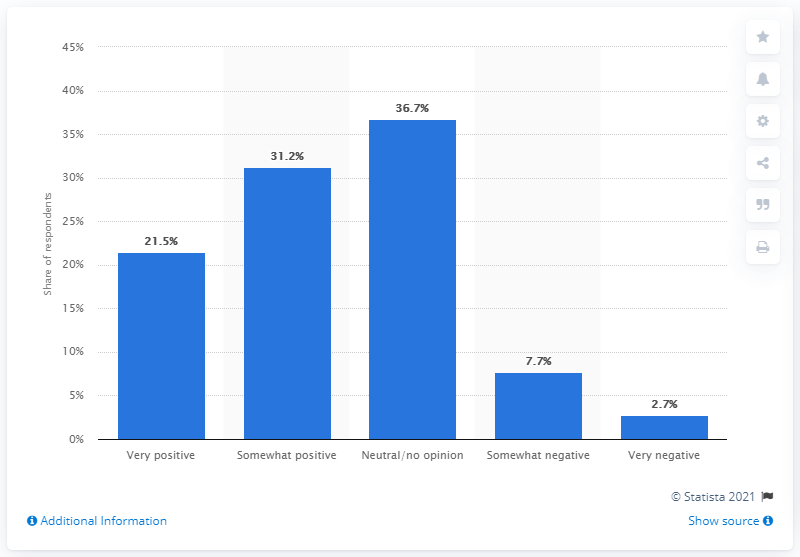Highlight a few significant elements in this photo. Approximately 31.2% of internet users viewed Yahoo's brand as somewhat positive. 